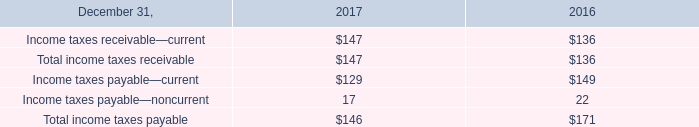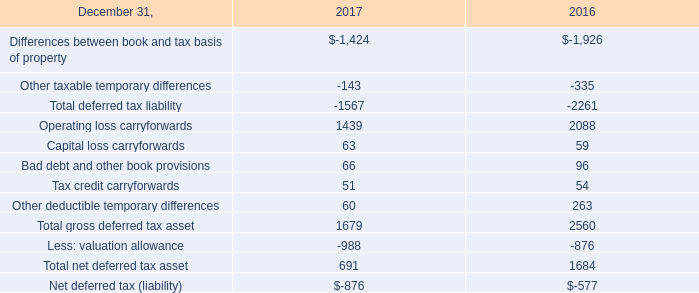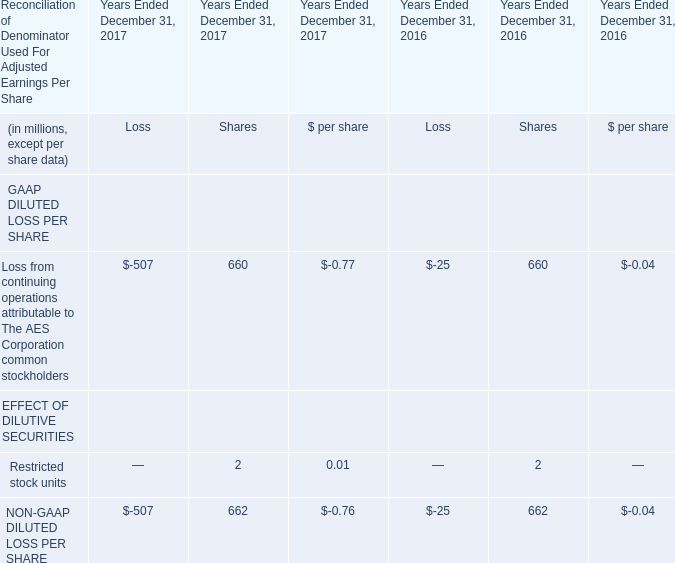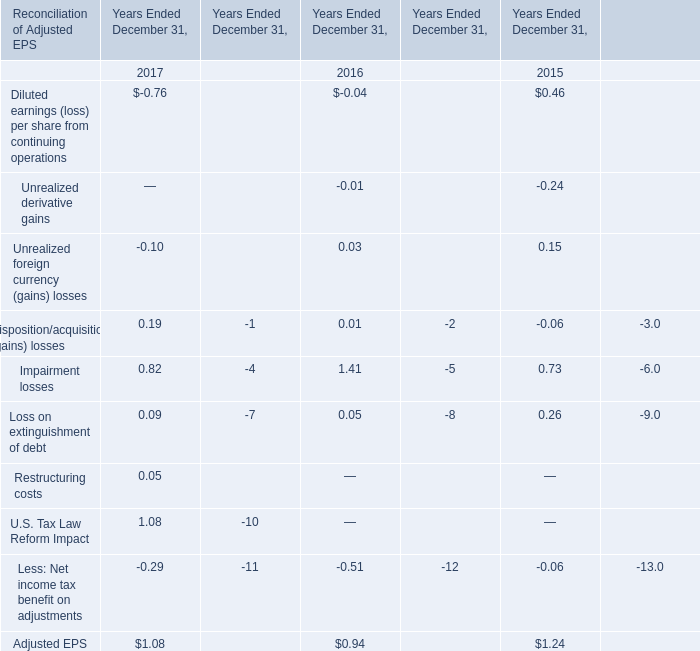What's the sum of the Unrealized derivative gains in table 3 in the years where Diluted earnings (loss) per share from continuing operations in table 3 greater than 0 ? 
Answer: -0.24. 